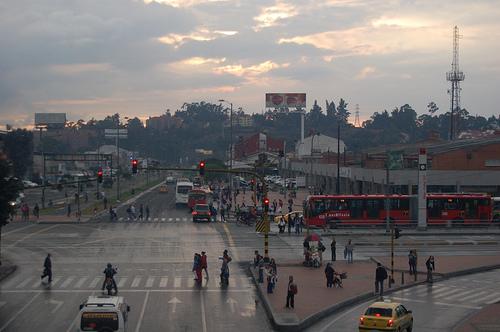Is this an urban or suburban area?
Give a very brief answer. Urban. What specific sort of roadway is this?
Keep it brief. Intersection. Is the bus in motion?
Answer briefly. Yes. Is the stop light green?
Give a very brief answer. No. What kind of scene is this?
Answer briefly. Intersection. How many people are seen?
Write a very short answer. Lot. Is the street so busy?
Keep it brief. Yes. Is this a rural scene?
Write a very short answer. No. What color is the top of the bus?
Answer briefly. Red. Is it night time?
Give a very brief answer. No. Is this a traffic jam?
Concise answer only. No. Overcast or sunny?
Write a very short answer. Overcast. Is this urban or suburban?
Write a very short answer. Urban. What color is the bus?
Quick response, please. Red. 